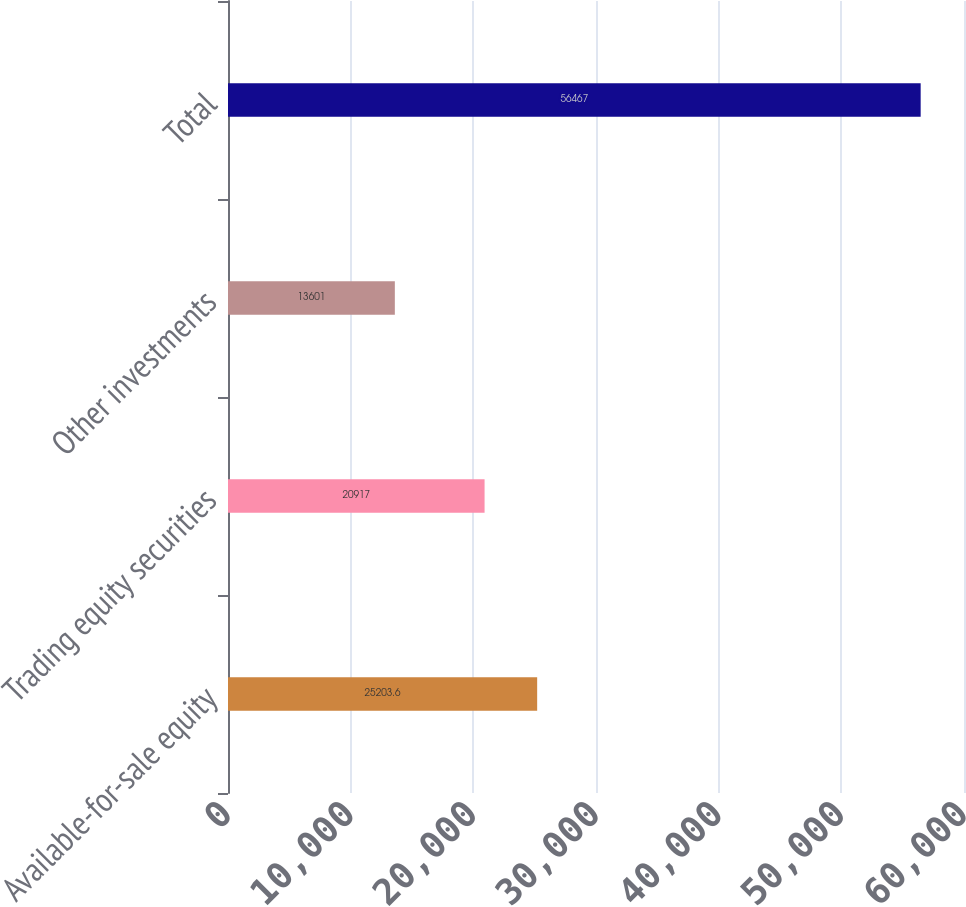Convert chart. <chart><loc_0><loc_0><loc_500><loc_500><bar_chart><fcel>Available-for-sale equity<fcel>Trading equity securities<fcel>Other investments<fcel>Total<nl><fcel>25203.6<fcel>20917<fcel>13601<fcel>56467<nl></chart> 